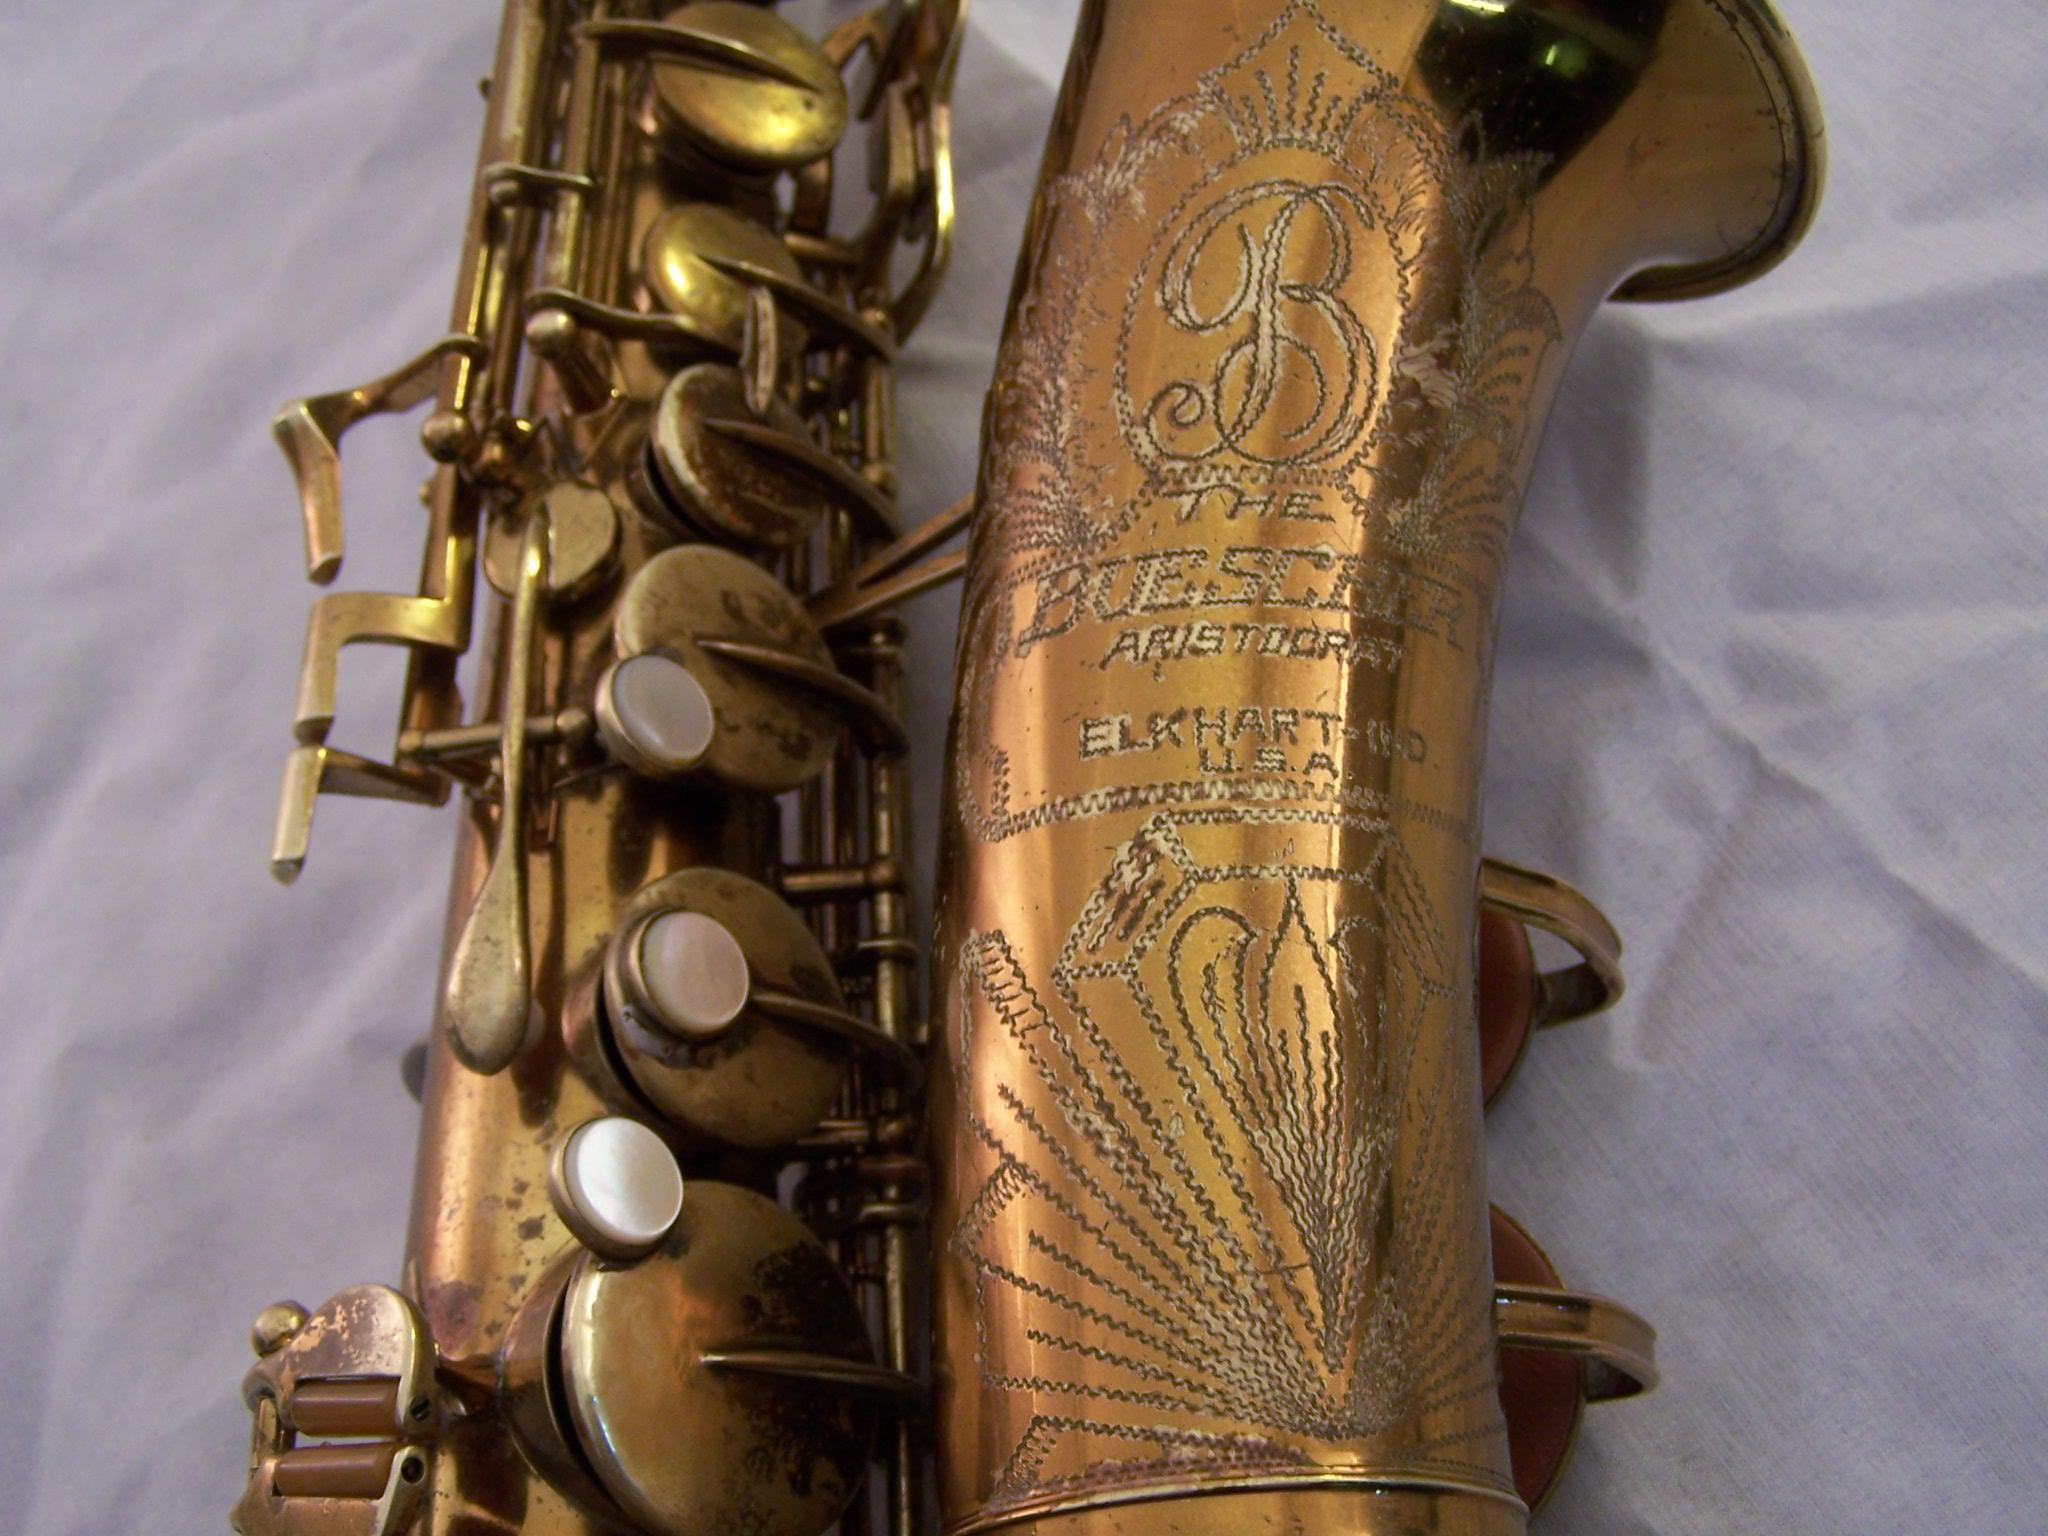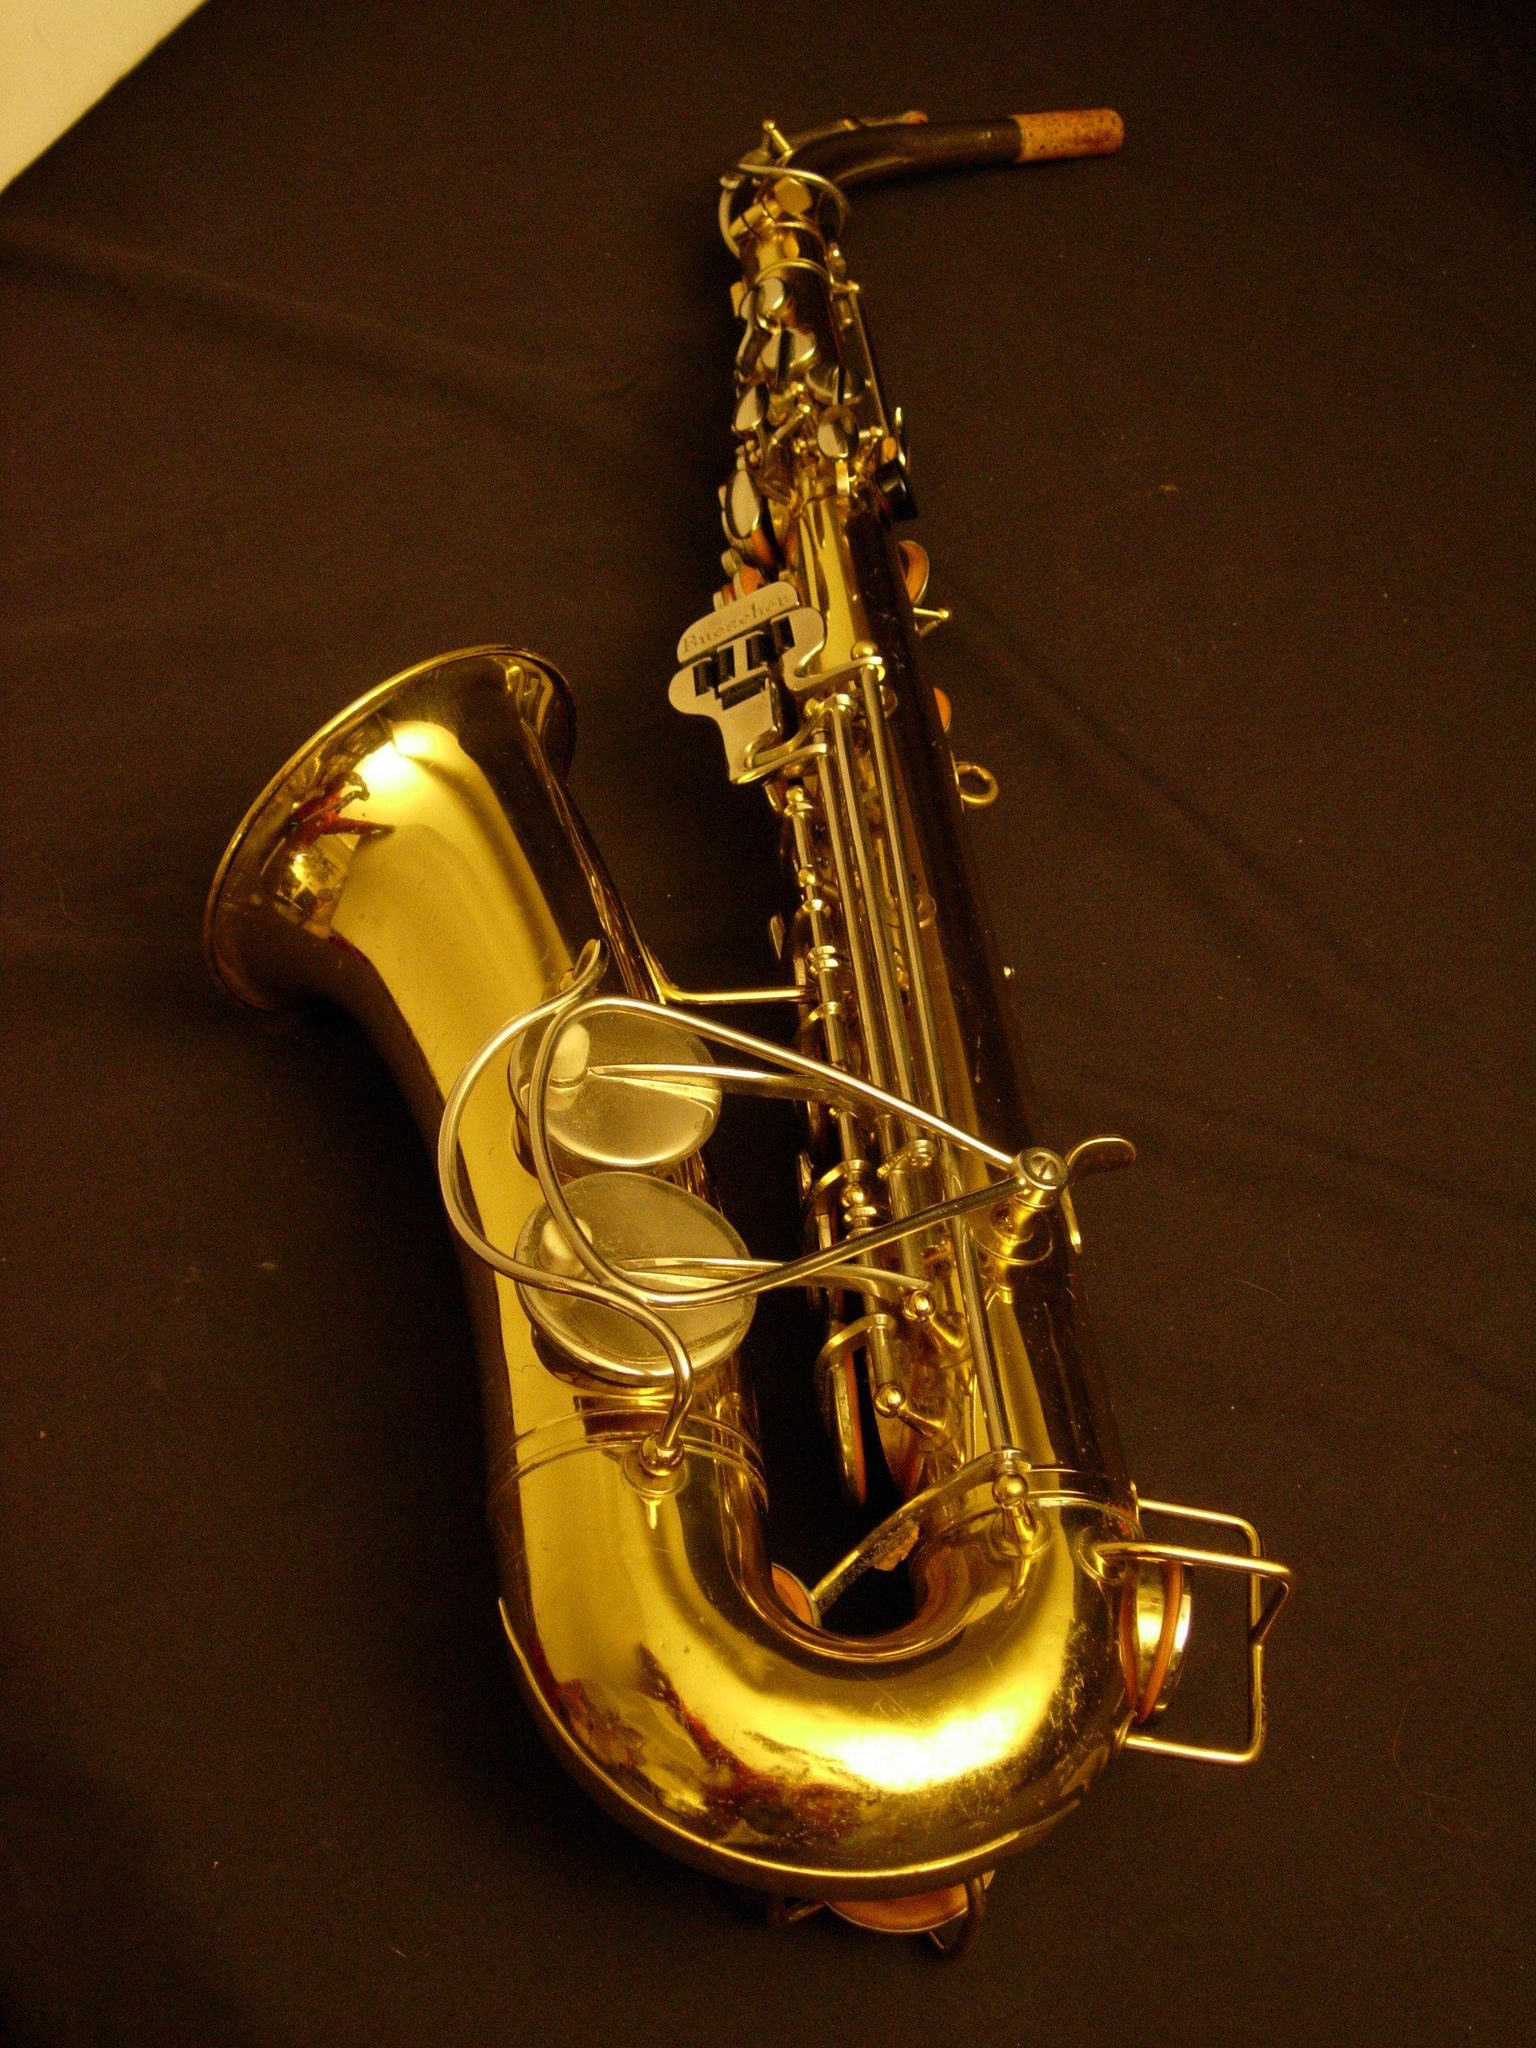The first image is the image on the left, the second image is the image on the right. Analyze the images presented: Is the assertion "All the sax's are facing the same direction." valid? Answer yes or no. No. The first image is the image on the left, the second image is the image on the right. Considering the images on both sides, is "One image shows the right-turned engraved bell of saxophone, and the other image shows one saxophone with mouthpiece intact." valid? Answer yes or no. Yes. 